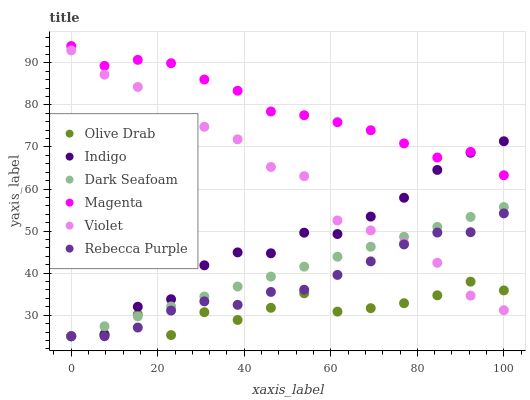Does Olive Drab have the minimum area under the curve?
Answer yes or no. Yes. Does Magenta have the maximum area under the curve?
Answer yes or no. Yes. Does Dark Seafoam have the minimum area under the curve?
Answer yes or no. No. Does Dark Seafoam have the maximum area under the curve?
Answer yes or no. No. Is Dark Seafoam the smoothest?
Answer yes or no. Yes. Is Olive Drab the roughest?
Answer yes or no. Yes. Is Rebecca Purple the smoothest?
Answer yes or no. No. Is Rebecca Purple the roughest?
Answer yes or no. No. Does Indigo have the lowest value?
Answer yes or no. Yes. Does Violet have the lowest value?
Answer yes or no. No. Does Magenta have the highest value?
Answer yes or no. Yes. Does Dark Seafoam have the highest value?
Answer yes or no. No. Is Violet less than Magenta?
Answer yes or no. Yes. Is Magenta greater than Olive Drab?
Answer yes or no. Yes. Does Rebecca Purple intersect Dark Seafoam?
Answer yes or no. Yes. Is Rebecca Purple less than Dark Seafoam?
Answer yes or no. No. Is Rebecca Purple greater than Dark Seafoam?
Answer yes or no. No. Does Violet intersect Magenta?
Answer yes or no. No. 